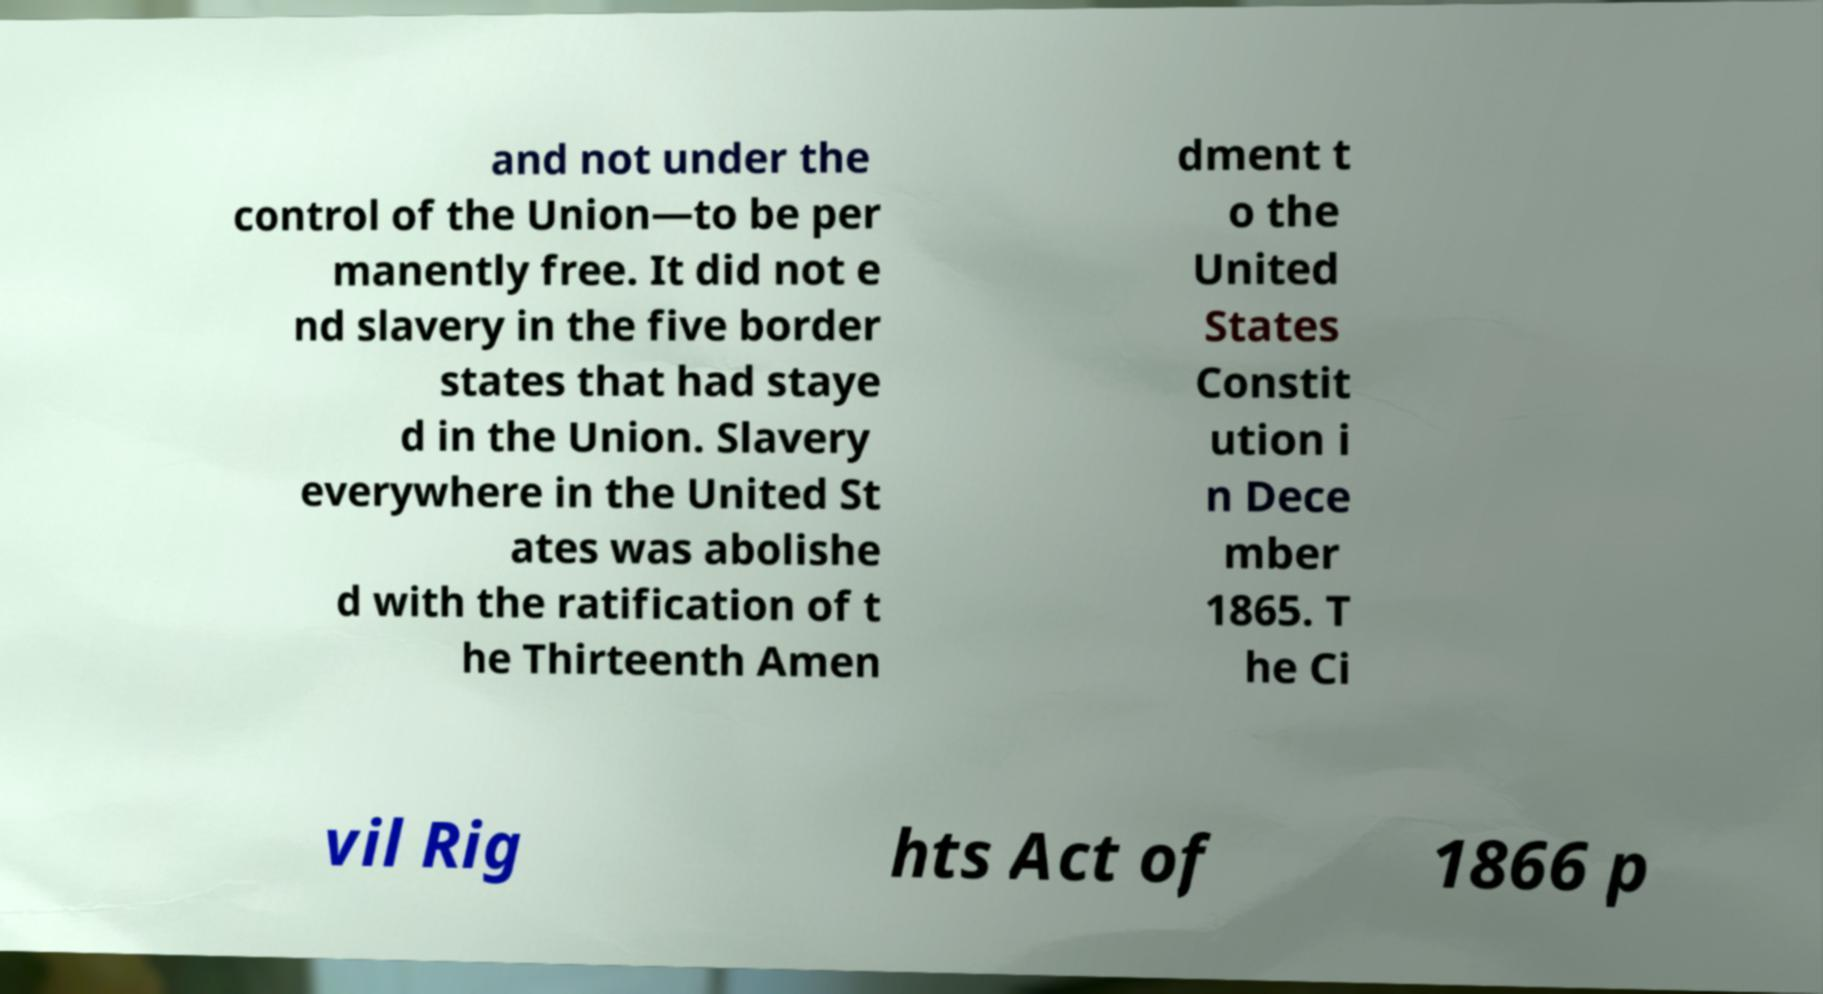There's text embedded in this image that I need extracted. Can you transcribe it verbatim? and not under the control of the Union—to be per manently free. It did not e nd slavery in the five border states that had staye d in the Union. Slavery everywhere in the United St ates was abolishe d with the ratification of t he Thirteenth Amen dment t o the United States Constit ution i n Dece mber 1865. T he Ci vil Rig hts Act of 1866 p 